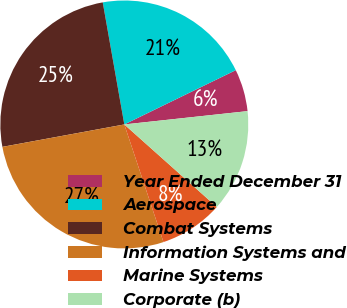<chart> <loc_0><loc_0><loc_500><loc_500><pie_chart><fcel>Year Ended December 31<fcel>Aerospace<fcel>Combat Systems<fcel>Information Systems and<fcel>Marine Systems<fcel>Corporate (b)<nl><fcel>5.5%<fcel>20.57%<fcel>25.11%<fcel>27.22%<fcel>8.29%<fcel>13.31%<nl></chart> 